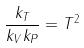Convert formula to latex. <formula><loc_0><loc_0><loc_500><loc_500>\frac { k _ { T } } { k _ { V } k _ { P } } = T ^ { 2 }</formula> 